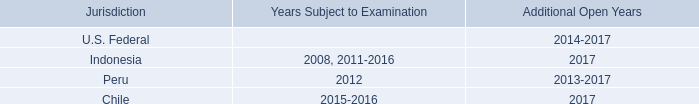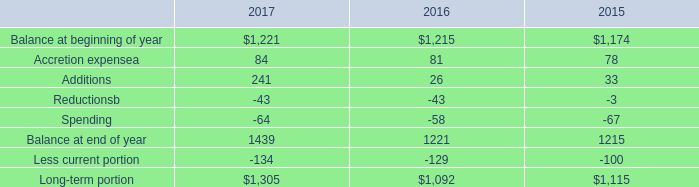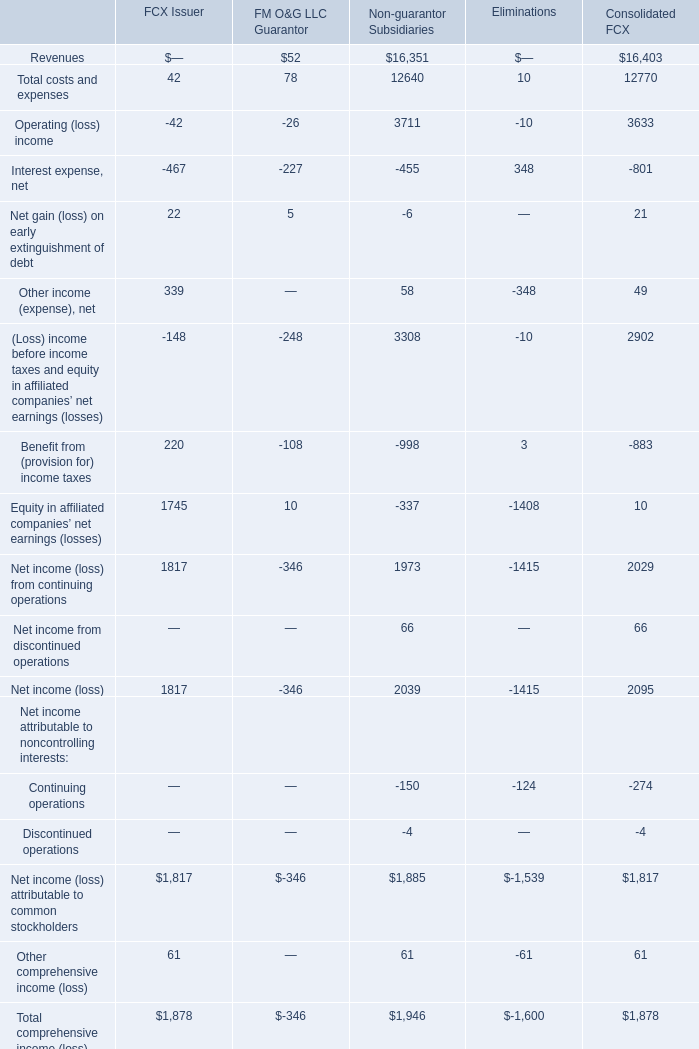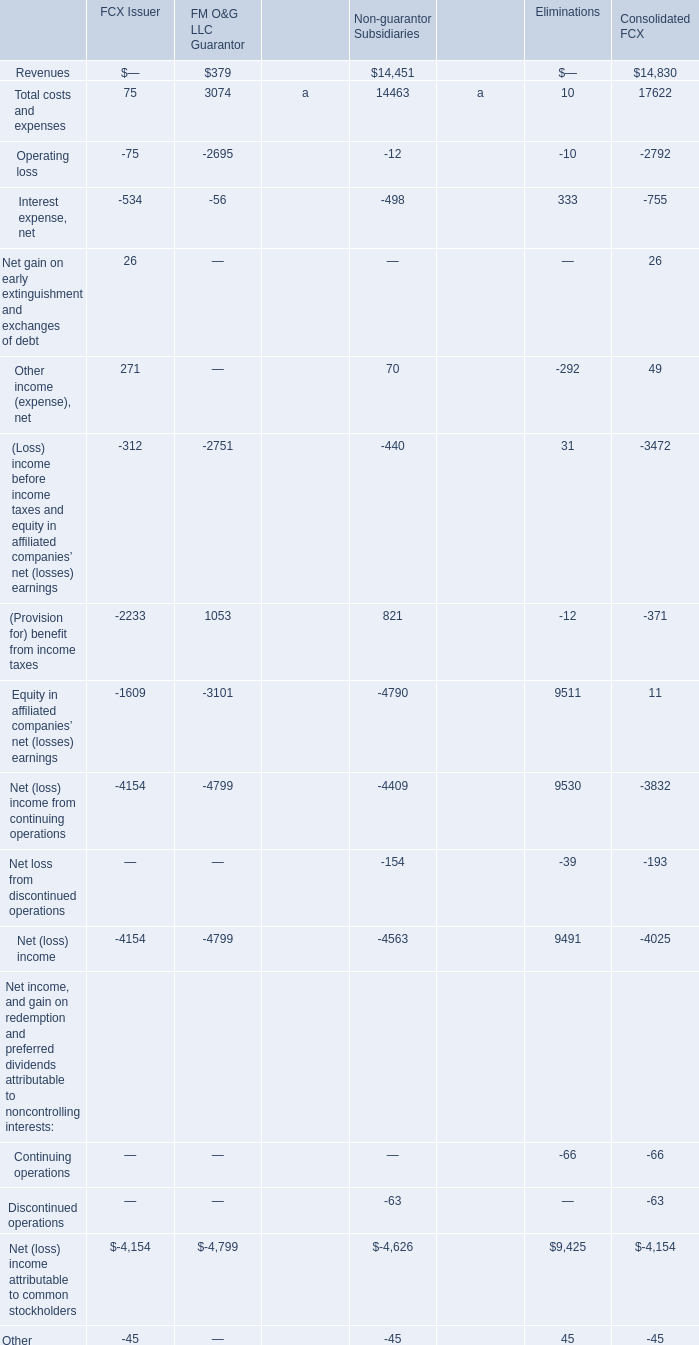What's the current growth rate of Total comprehensive income (loss)? 
Computations: ((1878 - 1600) / 1878)
Answer: 0.14803. 